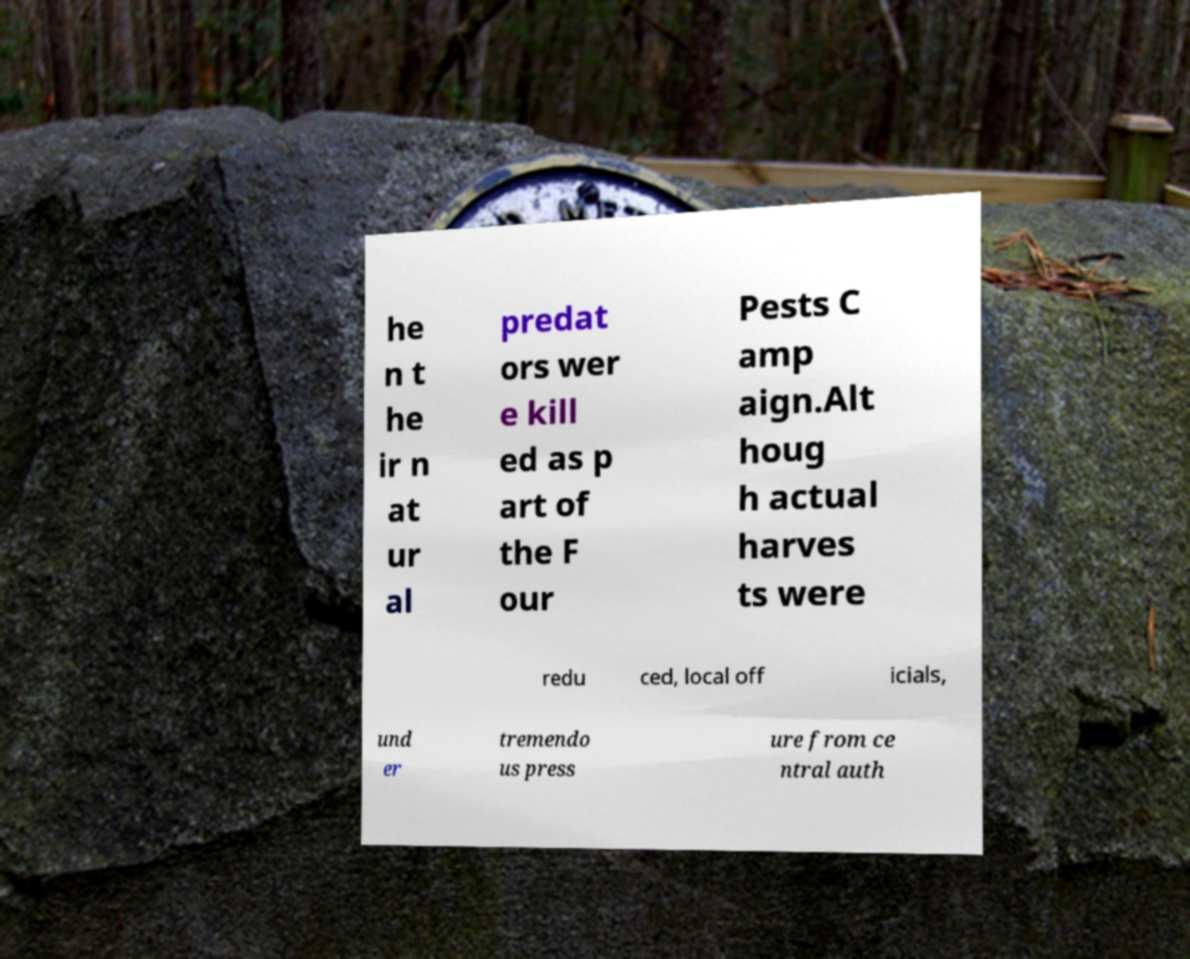What messages or text are displayed in this image? I need them in a readable, typed format. he n t he ir n at ur al predat ors wer e kill ed as p art of the F our Pests C amp aign.Alt houg h actual harves ts were redu ced, local off icials, und er tremendo us press ure from ce ntral auth 